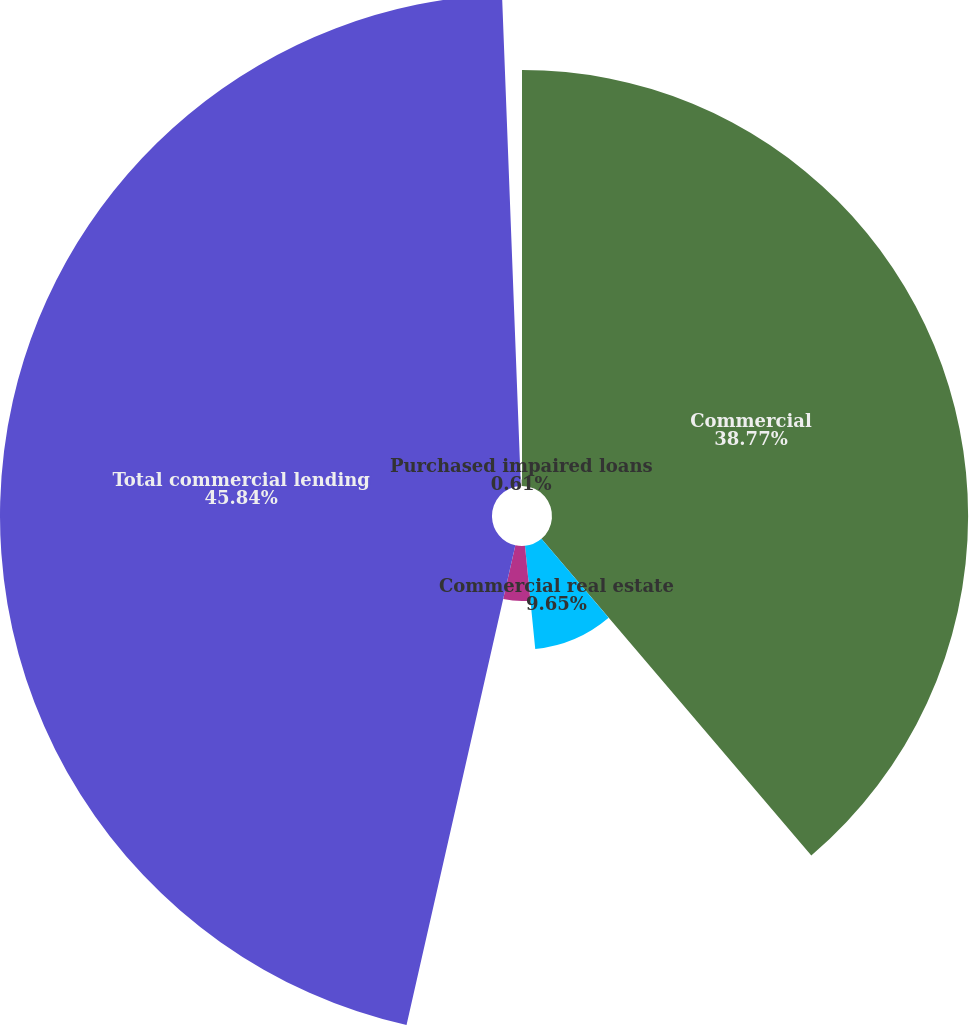<chart> <loc_0><loc_0><loc_500><loc_500><pie_chart><fcel>Commercial<fcel>Commercial real estate<fcel>Equipment lease financing<fcel>Total commercial lending<fcel>Purchased impaired loans<nl><fcel>38.77%<fcel>9.65%<fcel>5.13%<fcel>45.84%<fcel>0.61%<nl></chart> 